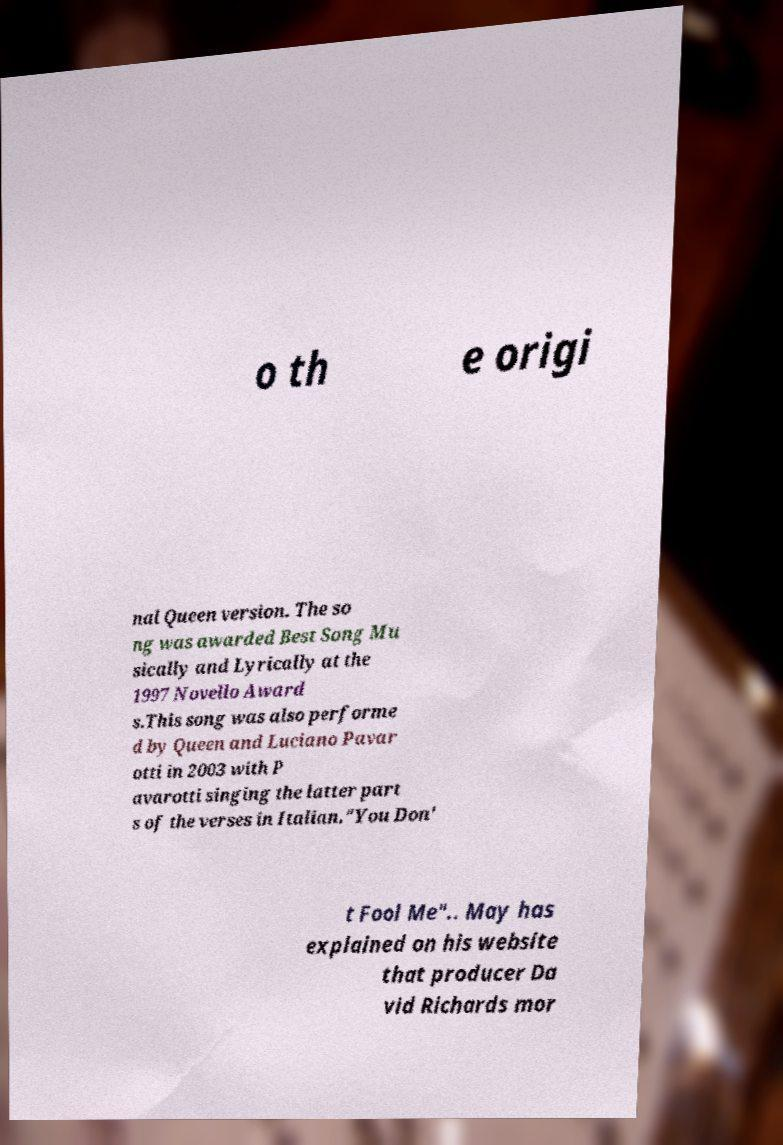There's text embedded in this image that I need extracted. Can you transcribe it verbatim? o th e origi nal Queen version. The so ng was awarded Best Song Mu sically and Lyrically at the 1997 Novello Award s.This song was also performe d by Queen and Luciano Pavar otti in 2003 with P avarotti singing the latter part s of the verses in Italian."You Don' t Fool Me".. May has explained on his website that producer Da vid Richards mor 